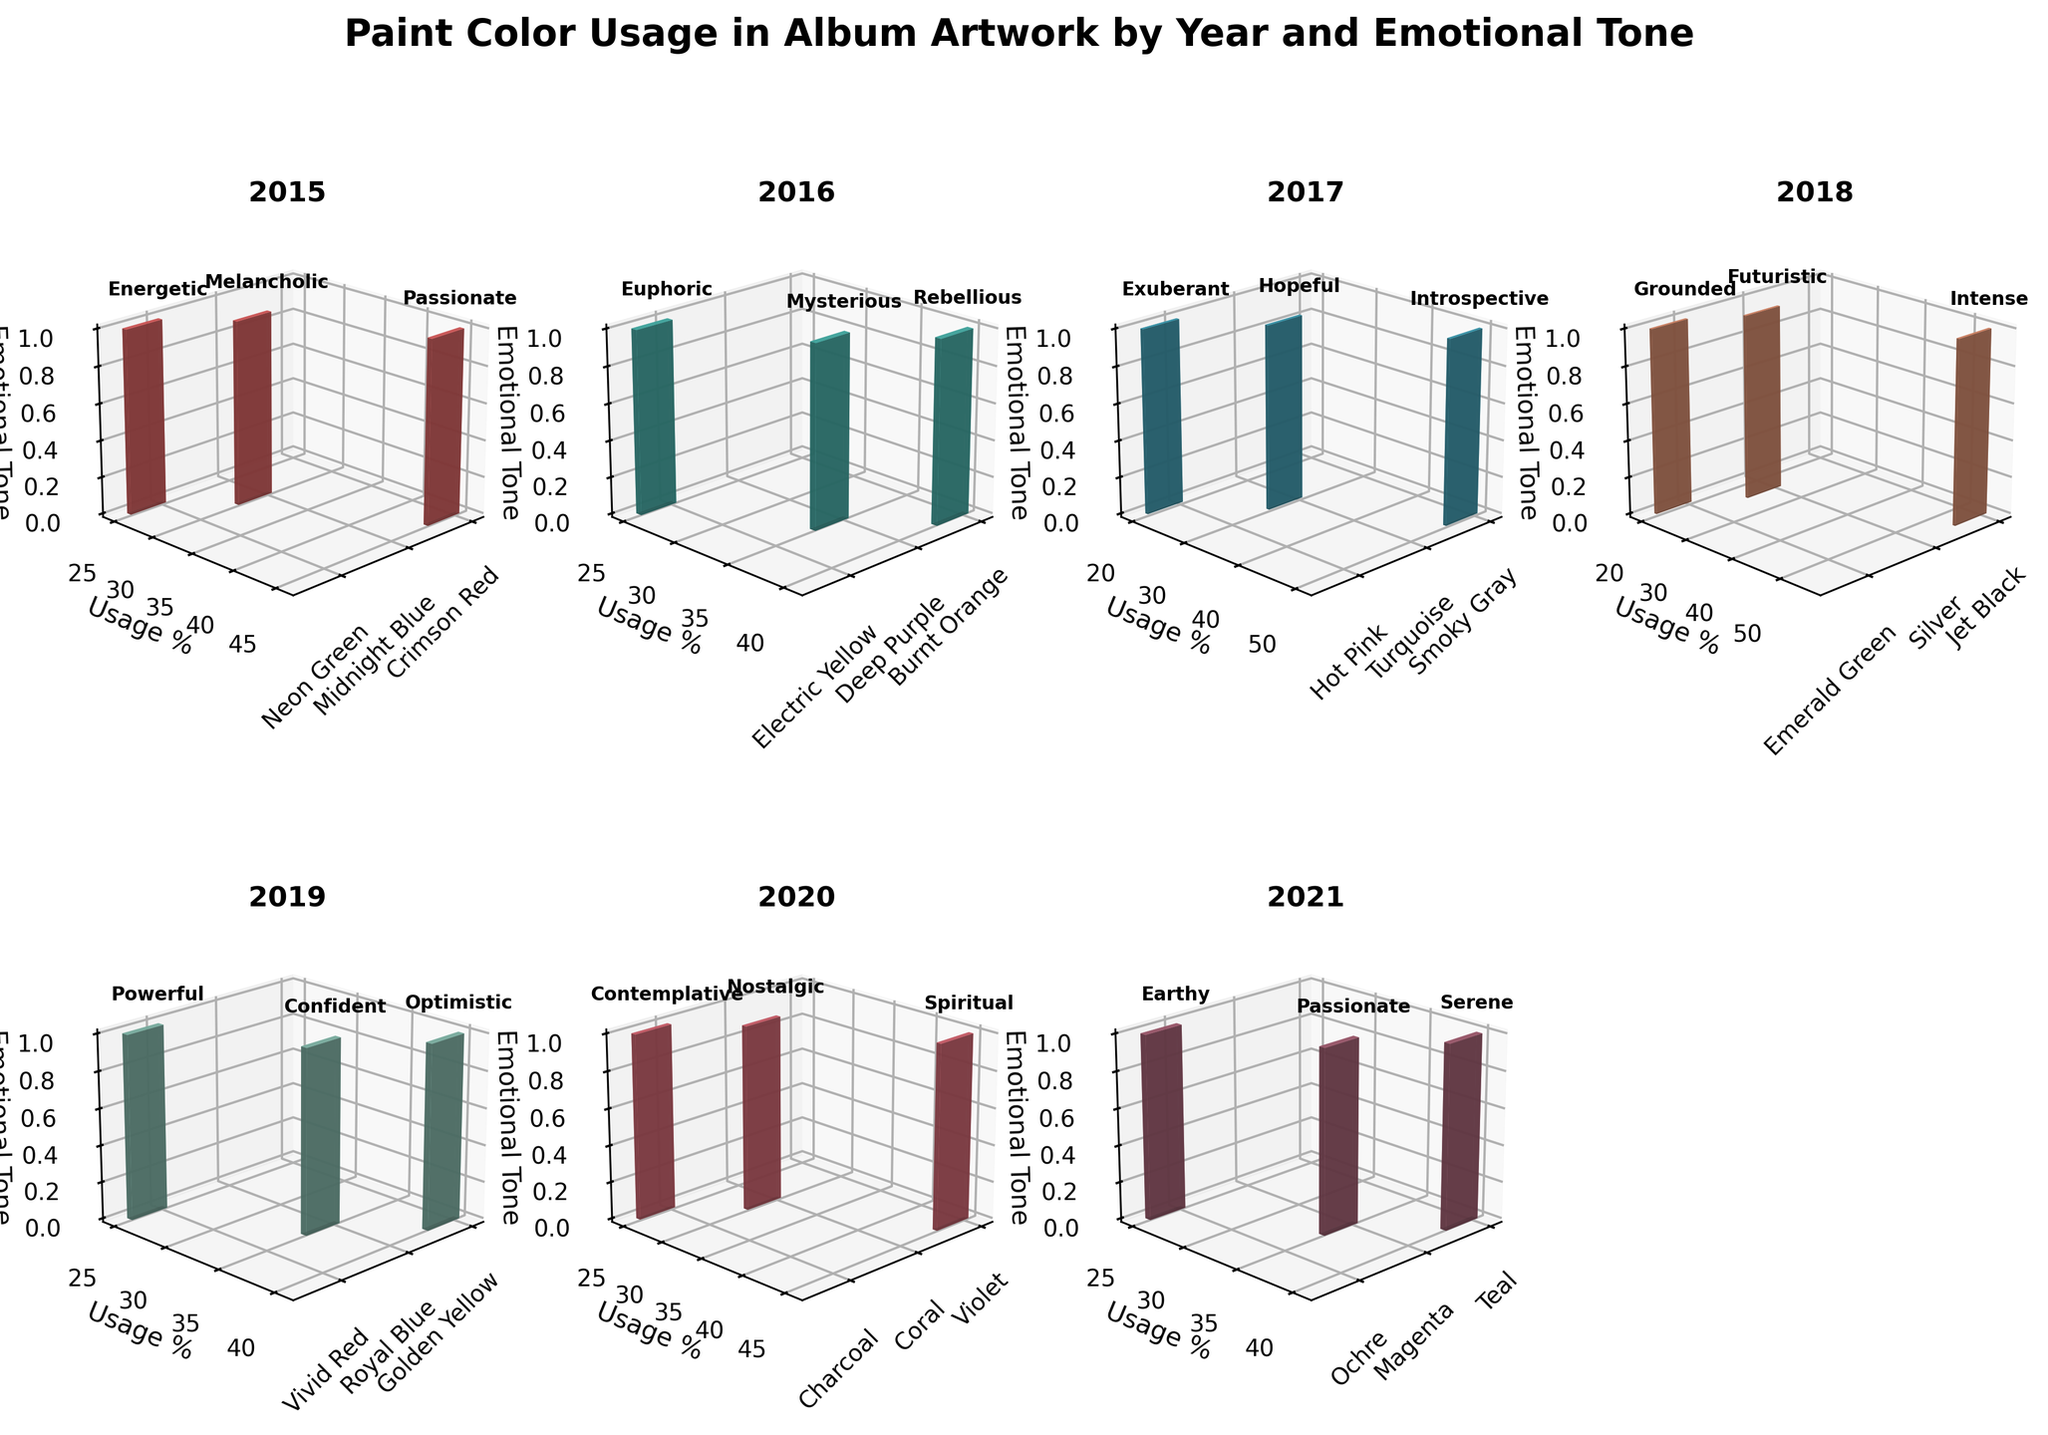What's the title of the figure? The title is located at the top of the figure and gives an overall description.
Answer: "Paint Color Usage in Album Artwork by Year and Emotional Tone" Which year has the highest percentage usage of the color with the tone "Intense"? The year with the highest percentage usage of the "Intense" tone is visually prominent in one subplot.
Answer: 2018 What color was used the most in 2017? Analyzing the bars in the 2017 subplot, the highest bar corresponds to the color with the highest usage.
Answer: Smoky Gray List the colors and corresponding emotional tones for the year 2019. By looking at the 2019 subplot, identify each bar's color and its corresponding emotional tone.
Answer: Golden Yellow (Optimistic), Royal Blue (Confident), Vivid Red (Powerful) Which emotional tone had the highest single-year usage percentage across all years? Examine each subplot for the highest individual bar and note the tone associated with it.
Answer: "Intense" with Jet Black in 2018 (55%) How many unique colors were used in 2020? Count the distinct color bars shown in the 2020 subplot.
Answer: 3 Compare the most used color in 2015 and 2016. Which one had a higher usage percentage and by how much? Identify the colors with the highest bars in 2015 and 2016 subplots. Then subtract the smaller percentage from the larger one.
Answer: Burnt Orange in 2016 had a higher percentage by 5% (45% in 2015 - 40% in 2016 = 5%) What is the total usage percentage of colors with the tone "Passionate" over the years? Sum up the usage percentages of all the tones labeled "Passionate" across different subplots.
Answer: 45% (2015) + 35% (2021) = 80% Which year featured the most diverse emotional tones, considering the number of unique tones? Count the number of distinct tones in each year's subplot and compare.
Answer: 2019 (3 tones) What trend can be observed in the usage of "Energetic" and "Euphoric" tones from 2015 to 2016? Compare the bars labeled "Energetic" and "Euphoric" in the 2015 and 2016 subplots and observe any increase or decrease.
Answer: Both decreased, "Energetic" from 25% to 0% and "Euphoric" from 25% to 0% 